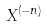<formula> <loc_0><loc_0><loc_500><loc_500>X ^ { ( - n ) }</formula> 